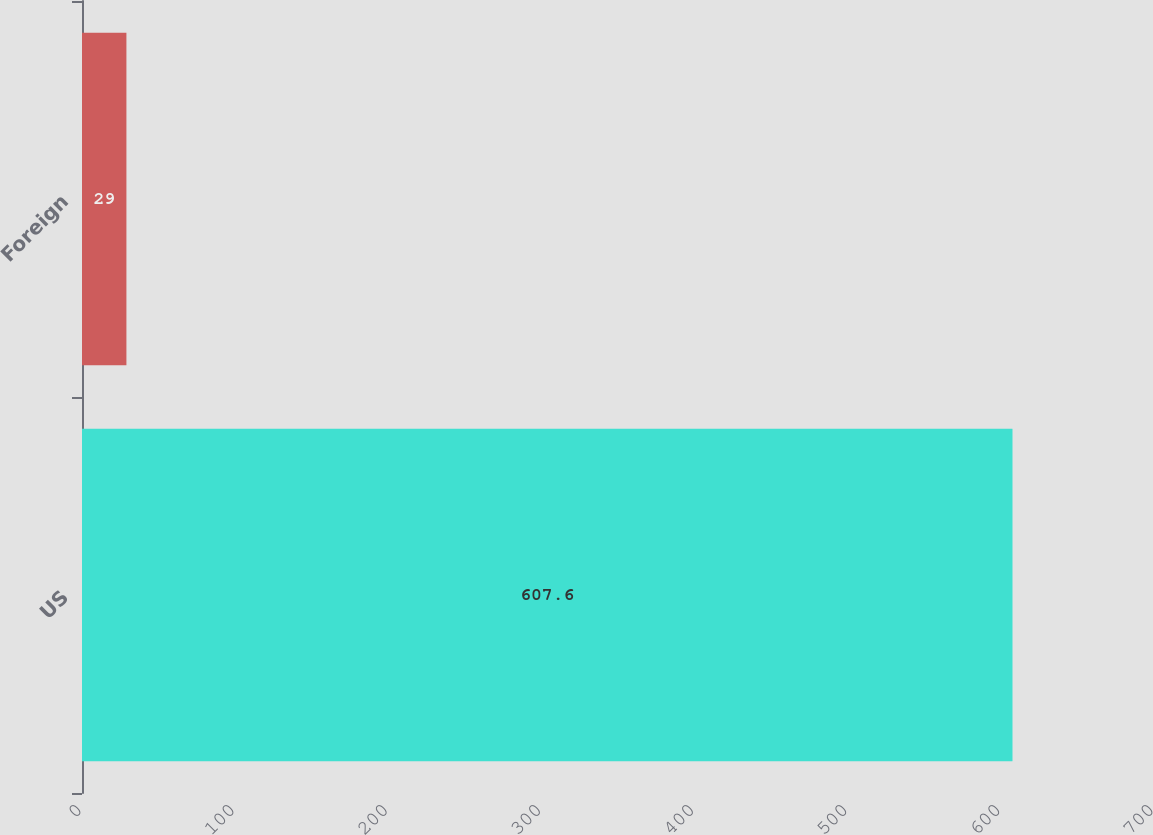Convert chart. <chart><loc_0><loc_0><loc_500><loc_500><bar_chart><fcel>US<fcel>Foreign<nl><fcel>607.6<fcel>29<nl></chart> 